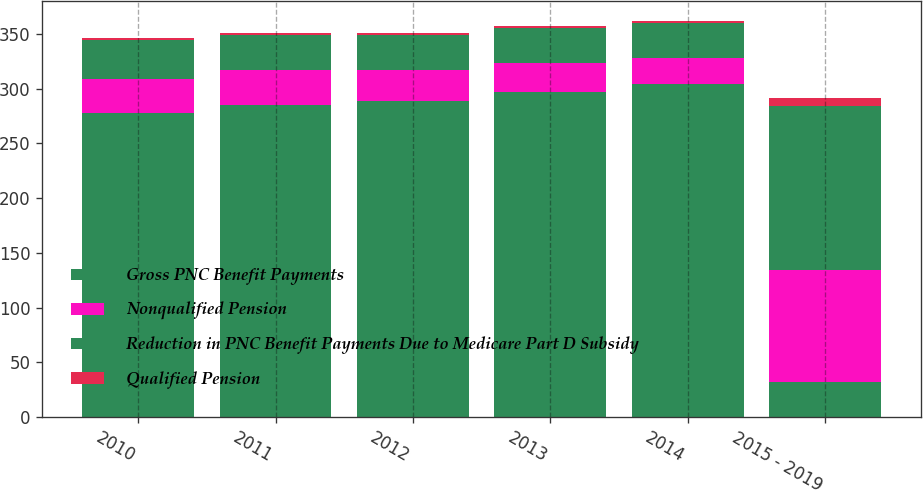Convert chart. <chart><loc_0><loc_0><loc_500><loc_500><stacked_bar_chart><ecel><fcel>2010<fcel>2011<fcel>2012<fcel>2013<fcel>2014<fcel>2015 - 2019<nl><fcel>Gross PNC Benefit Payments<fcel>278<fcel>285<fcel>289<fcel>297<fcel>304<fcel>32<nl><fcel>Nonqualified Pension<fcel>31<fcel>32<fcel>28<fcel>26<fcel>24<fcel>102<nl><fcel>Reduction in PNC Benefit Payments Due to Medicare Part D Subsidy<fcel>35<fcel>32<fcel>32<fcel>32<fcel>32<fcel>150<nl><fcel>Qualified Pension<fcel>2<fcel>2<fcel>2<fcel>2<fcel>2<fcel>7<nl></chart> 